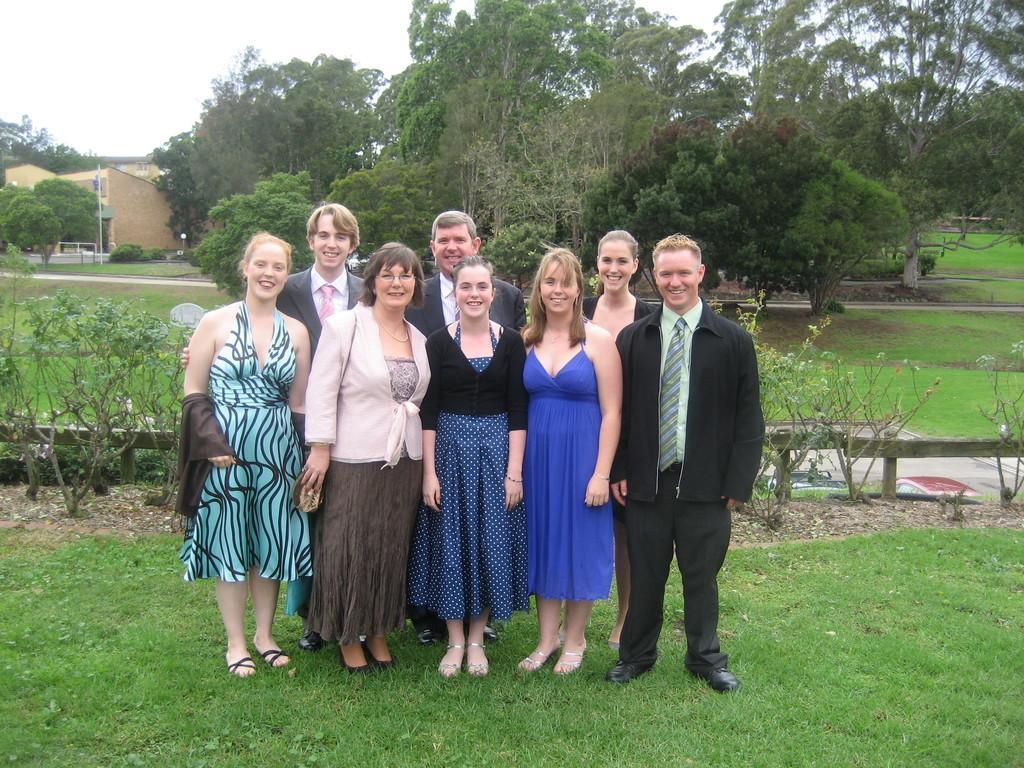Please provide a concise description of this image. In this image, we can see a group of people are standing. They are watching and smiling. At the bottom, we can see grass. Background there are few plants, poles, trees, houses and sky. 